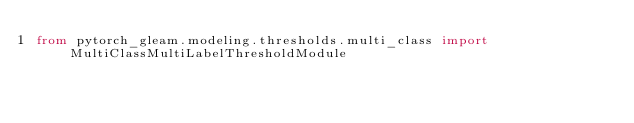Convert code to text. <code><loc_0><loc_0><loc_500><loc_500><_Python_>from pytorch_gleam.modeling.thresholds.multi_class import MultiClassMultiLabelThresholdModule
</code> 